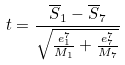Convert formula to latex. <formula><loc_0><loc_0><loc_500><loc_500>t = \frac { \overline { S } _ { 1 } - \overline { S } _ { 7 } } { \sqrt { \frac { e _ { 1 } ^ { 7 } } { M _ { 1 } } + \frac { e _ { 7 } ^ { 7 } } { M _ { 7 } } } }</formula> 